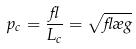<formula> <loc_0><loc_0><loc_500><loc_500>p _ { c } = \frac { \gamma } { L _ { c } } = \sqrt { \gamma \rho g }</formula> 